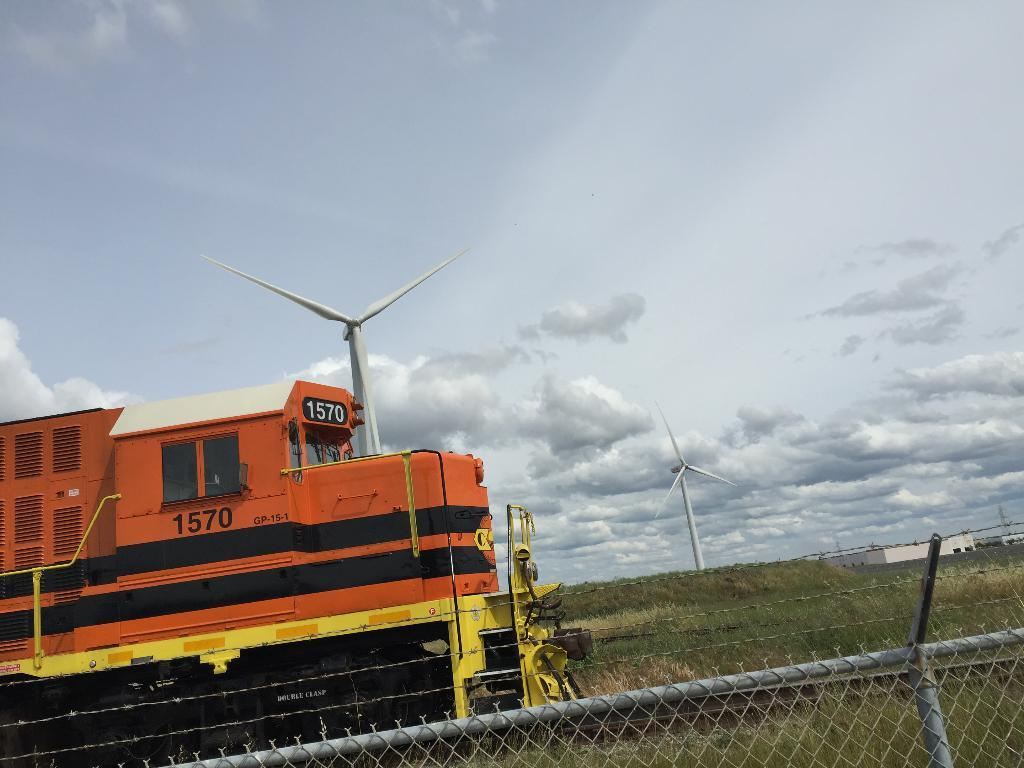What is the main subject of the image? There is a train on the track in the image. What can be seen at the bottom of the image? There is a fence at the bottom of the image. What is visible in the background of the image? Windmills, grass, a building, and the sky are visible in the background of the image. What type of joke is being told by the train in the image? There is no indication in the image that a joke is being told, as trains do not have the ability to tell jokes. 